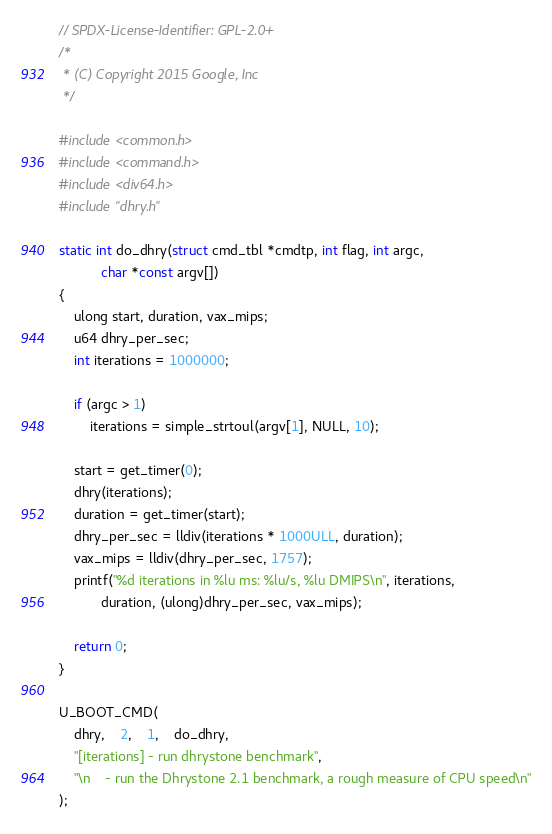<code> <loc_0><loc_0><loc_500><loc_500><_C_>// SPDX-License-Identifier: GPL-2.0+
/*
 * (C) Copyright 2015 Google, Inc
 */

#include <common.h>
#include <command.h>
#include <div64.h>
#include "dhry.h"

static int do_dhry(struct cmd_tbl *cmdtp, int flag, int argc,
		   char *const argv[])
{
	ulong start, duration, vax_mips;
	u64 dhry_per_sec;
	int iterations = 1000000;

	if (argc > 1)
		iterations = simple_strtoul(argv[1], NULL, 10);

	start = get_timer(0);
	dhry(iterations);
	duration = get_timer(start);
	dhry_per_sec = lldiv(iterations * 1000ULL, duration);
	vax_mips = lldiv(dhry_per_sec, 1757);
	printf("%d iterations in %lu ms: %lu/s, %lu DMIPS\n", iterations,
	       duration, (ulong)dhry_per_sec, vax_mips);

	return 0;
}

U_BOOT_CMD(
	dhry,	2,	1,	do_dhry,
	"[iterations] - run dhrystone benchmark",
	"\n    - run the Dhrystone 2.1 benchmark, a rough measure of CPU speed\n"
);
</code> 